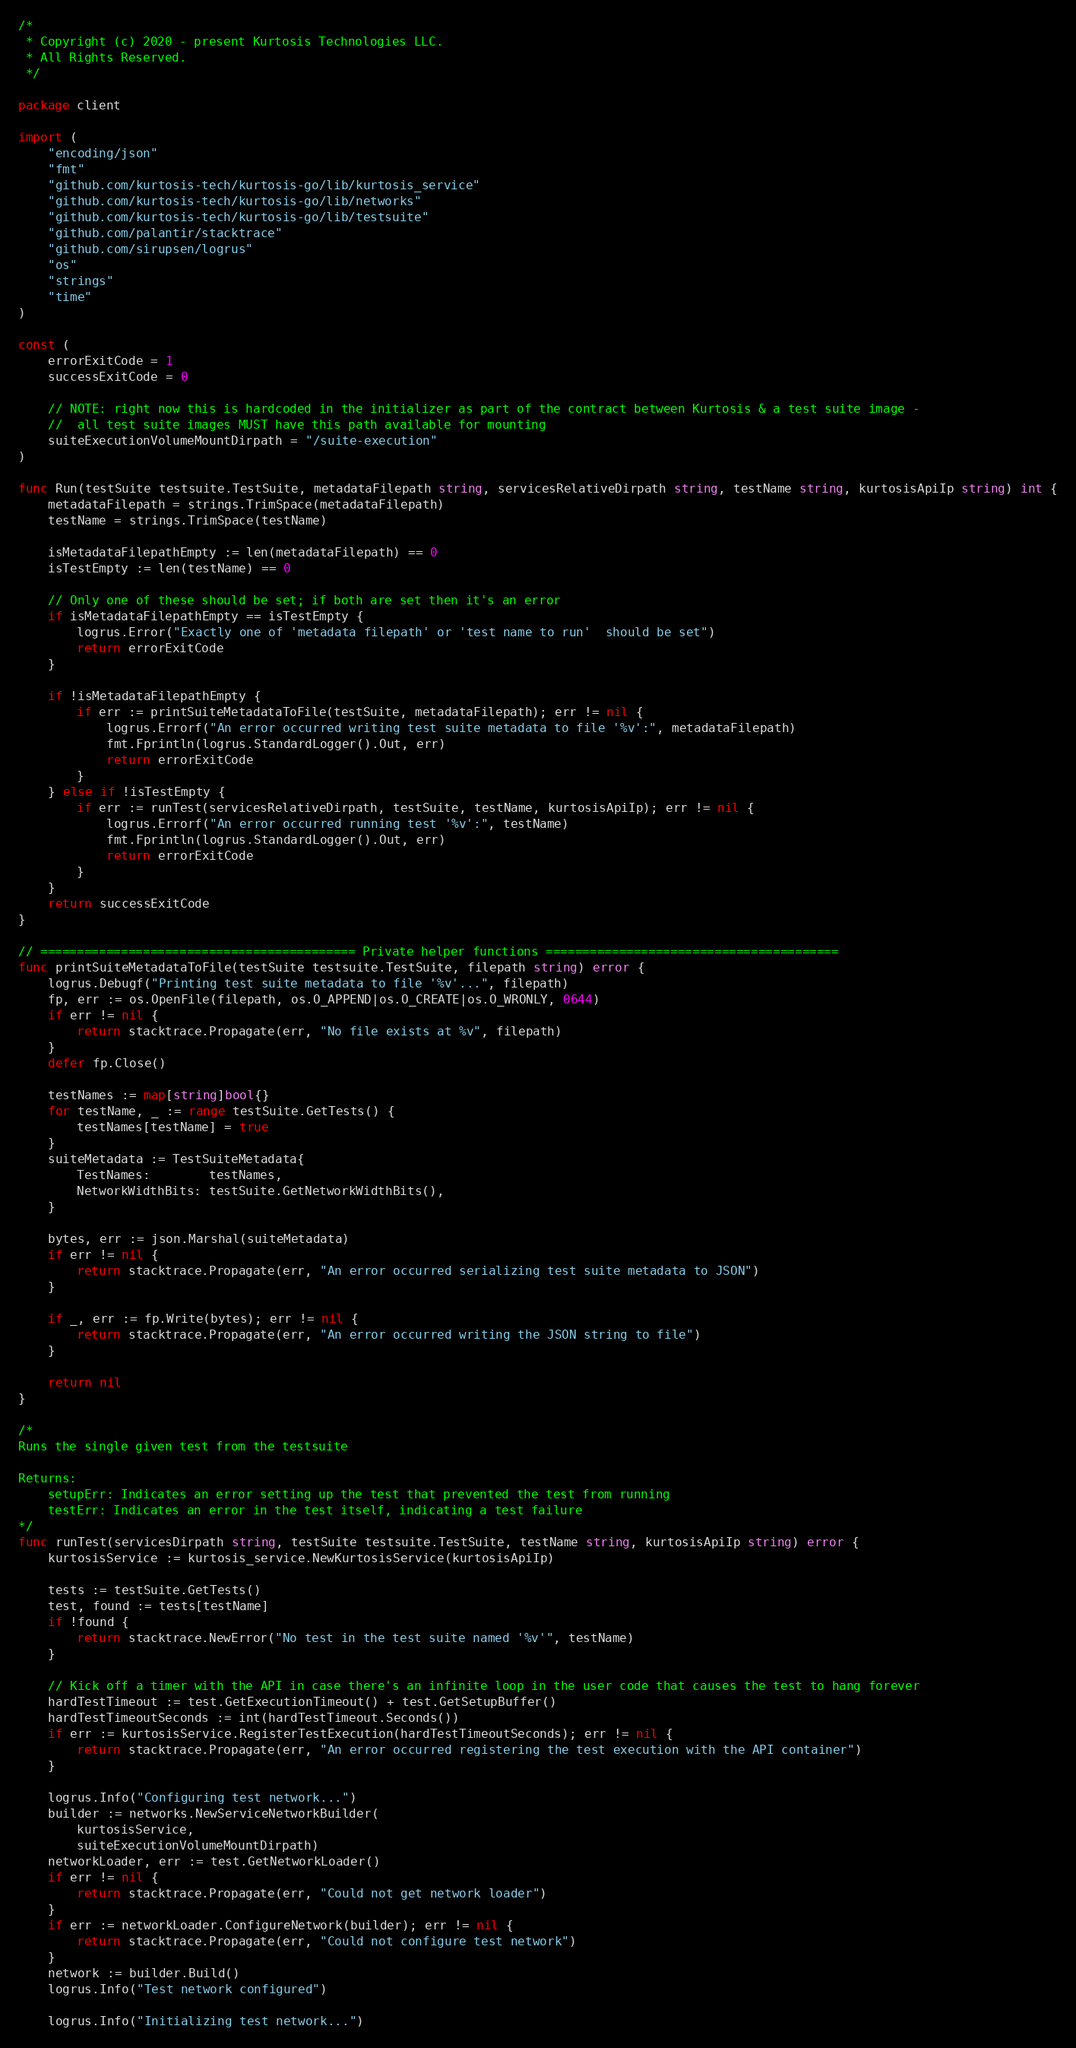Convert code to text. <code><loc_0><loc_0><loc_500><loc_500><_Go_>/*
 * Copyright (c) 2020 - present Kurtosis Technologies LLC.
 * All Rights Reserved.
 */

package client

import (
	"encoding/json"
	"fmt"
	"github.com/kurtosis-tech/kurtosis-go/lib/kurtosis_service"
	"github.com/kurtosis-tech/kurtosis-go/lib/networks"
	"github.com/kurtosis-tech/kurtosis-go/lib/testsuite"
	"github.com/palantir/stacktrace"
	"github.com/sirupsen/logrus"
	"os"
	"strings"
	"time"
)

const (
	errorExitCode = 1
	successExitCode = 0

	// NOTE: right now this is hardcoded in the initializer as part of the contract between Kurtosis & a test suite image -
	//  all test suite images MUST have this path available for mounting
	suiteExecutionVolumeMountDirpath = "/suite-execution"
)

func Run(testSuite testsuite.TestSuite, metadataFilepath string, servicesRelativeDirpath string, testName string, kurtosisApiIp string) int {
	metadataFilepath = strings.TrimSpace(metadataFilepath)
	testName = strings.TrimSpace(testName)

	isMetadataFilepathEmpty := len(metadataFilepath) == 0
	isTestEmpty := len(testName) == 0

	// Only one of these should be set; if both are set then it's an error
	if isMetadataFilepathEmpty == isTestEmpty {
		logrus.Error("Exactly one of 'metadata filepath' or 'test name to run'  should be set")
		return errorExitCode
	}

	if !isMetadataFilepathEmpty {
		if err := printSuiteMetadataToFile(testSuite, metadataFilepath); err != nil {
			logrus.Errorf("An error occurred writing test suite metadata to file '%v':", metadataFilepath)
			fmt.Fprintln(logrus.StandardLogger().Out, err)
			return errorExitCode
		}
	} else if !isTestEmpty {
		if err := runTest(servicesRelativeDirpath, testSuite, testName, kurtosisApiIp); err != nil {
			logrus.Errorf("An error occurred running test '%v':", testName)
			fmt.Fprintln(logrus.StandardLogger().Out, err)
			return errorExitCode
		}
	}
	return successExitCode
}

// =========================================== Private helper functions ========================================
func printSuiteMetadataToFile(testSuite testsuite.TestSuite, filepath string) error {
	logrus.Debugf("Printing test suite metadata to file '%v'...", filepath)
	fp, err := os.OpenFile(filepath, os.O_APPEND|os.O_CREATE|os.O_WRONLY, 0644)
	if err != nil {
		return stacktrace.Propagate(err, "No file exists at %v", filepath)
	}
	defer fp.Close()

	testNames := map[string]bool{}
	for testName, _ := range testSuite.GetTests() {
		testNames[testName] = true
	}
	suiteMetadata := TestSuiteMetadata{
		TestNames:        testNames,
		NetworkWidthBits: testSuite.GetNetworkWidthBits(),
	}

	bytes, err := json.Marshal(suiteMetadata)
	if err != nil {
		return stacktrace.Propagate(err, "An error occurred serializing test suite metadata to JSON")
	}

	if _, err := fp.Write(bytes); err != nil {
		return stacktrace.Propagate(err, "An error occurred writing the JSON string to file")
	}

	return nil
}

/*
Runs the single given test from the testsuite

Returns:
	setupErr: Indicates an error setting up the test that prevented the test from running
	testErr: Indicates an error in the test itself, indicating a test failure
*/
func runTest(servicesDirpath string, testSuite testsuite.TestSuite, testName string, kurtosisApiIp string) error {
	kurtosisService := kurtosis_service.NewKurtosisService(kurtosisApiIp)

	tests := testSuite.GetTests()
	test, found := tests[testName]
	if !found {
		return stacktrace.NewError("No test in the test suite named '%v'", testName)
	}

	// Kick off a timer with the API in case there's an infinite loop in the user code that causes the test to hang forever
	hardTestTimeout := test.GetExecutionTimeout() + test.GetSetupBuffer()
	hardTestTimeoutSeconds := int(hardTestTimeout.Seconds())
	if err := kurtosisService.RegisterTestExecution(hardTestTimeoutSeconds); err != nil {
		return stacktrace.Propagate(err, "An error occurred registering the test execution with the API container")
	}

	logrus.Info("Configuring test network...")
	builder := networks.NewServiceNetworkBuilder(
		kurtosisService,
		suiteExecutionVolumeMountDirpath)
	networkLoader, err := test.GetNetworkLoader()
	if err != nil {
		return stacktrace.Propagate(err, "Could not get network loader")
	}
	if err := networkLoader.ConfigureNetwork(builder); err != nil {
		return stacktrace.Propagate(err, "Could not configure test network")
	}
	network := builder.Build()
	logrus.Info("Test network configured")

	logrus.Info("Initializing test network...")</code> 